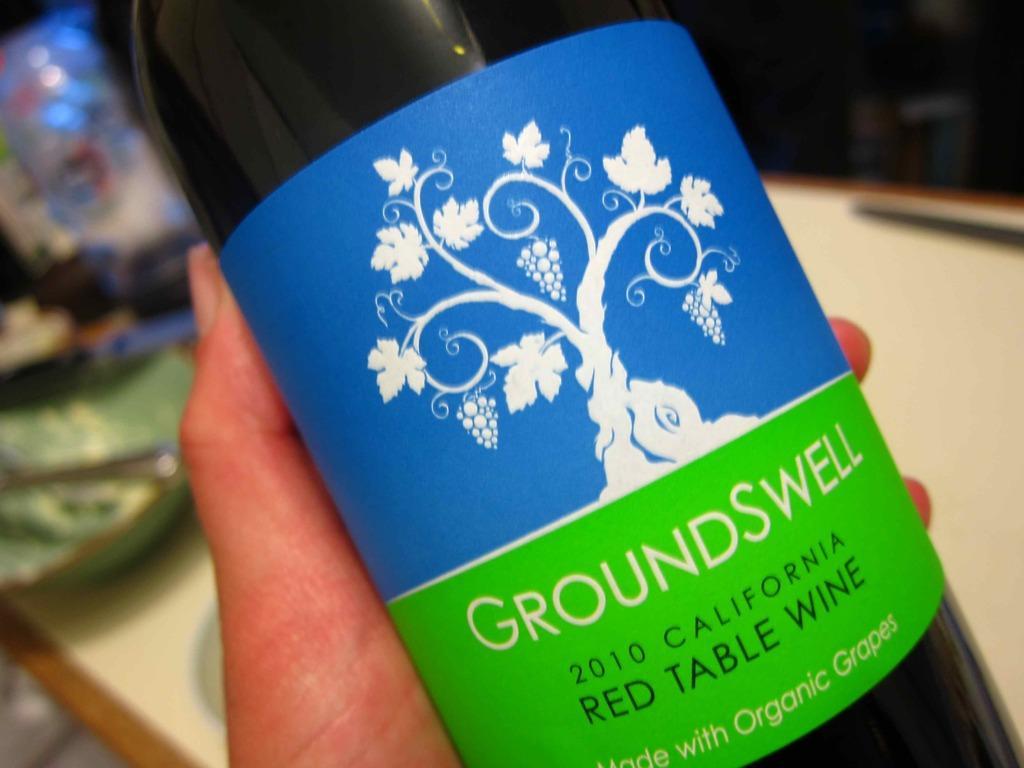Describe this image in one or two sentences. In this image I can see a bottle where GroundSwell is written on it. I can also see hand of a person. 